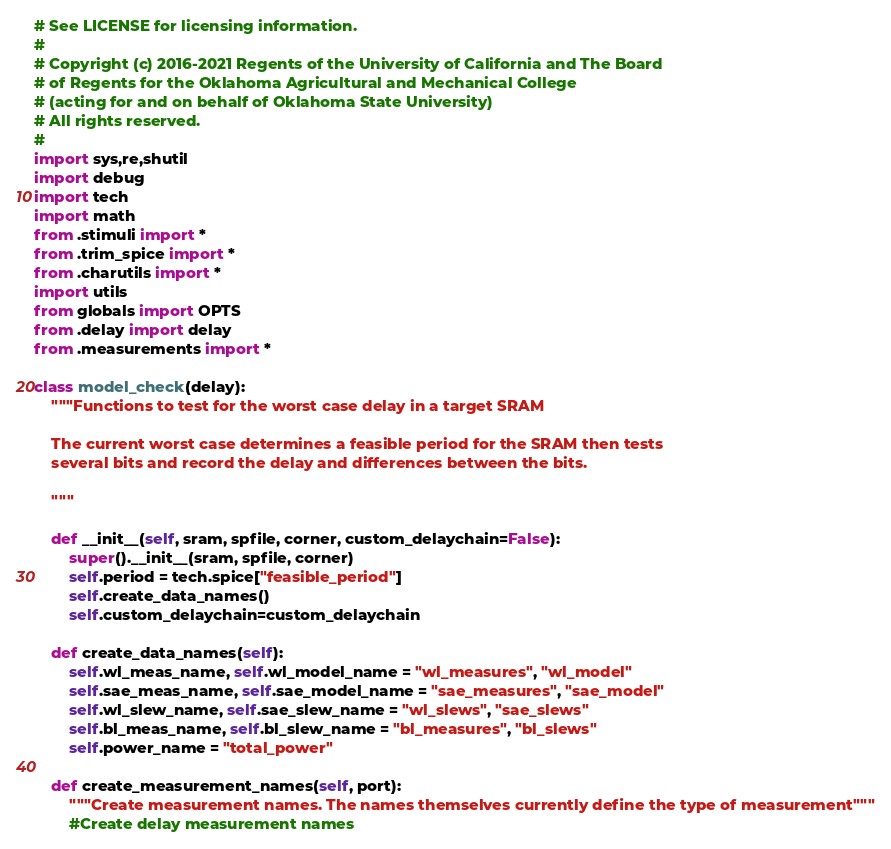<code> <loc_0><loc_0><loc_500><loc_500><_Python_># See LICENSE for licensing information.
#
# Copyright (c) 2016-2021 Regents of the University of California and The Board
# of Regents for the Oklahoma Agricultural and Mechanical College
# (acting for and on behalf of Oklahoma State University)
# All rights reserved.
#
import sys,re,shutil
import debug
import tech
import math
from .stimuli import *
from .trim_spice import *
from .charutils import *
import utils
from globals import OPTS
from .delay import delay
from .measurements import *

class model_check(delay):
    """Functions to test for the worst case delay in a target SRAM

    The current worst case determines a feasible period for the SRAM then tests
    several bits and record the delay and differences between the bits.

    """

    def __init__(self, sram, spfile, corner, custom_delaychain=False):
        super().__init__(sram, spfile, corner)
        self.period = tech.spice["feasible_period"]
        self.create_data_names()
        self.custom_delaychain=custom_delaychain

    def create_data_names(self):
        self.wl_meas_name, self.wl_model_name = "wl_measures", "wl_model"
        self.sae_meas_name, self.sae_model_name = "sae_measures", "sae_model"
        self.wl_slew_name, self.sae_slew_name = "wl_slews", "sae_slews"
        self.bl_meas_name, self.bl_slew_name = "bl_measures", "bl_slews"
        self.power_name = "total_power"

    def create_measurement_names(self, port):
        """Create measurement names. The names themselves currently define the type of measurement"""
        #Create delay measurement names</code> 